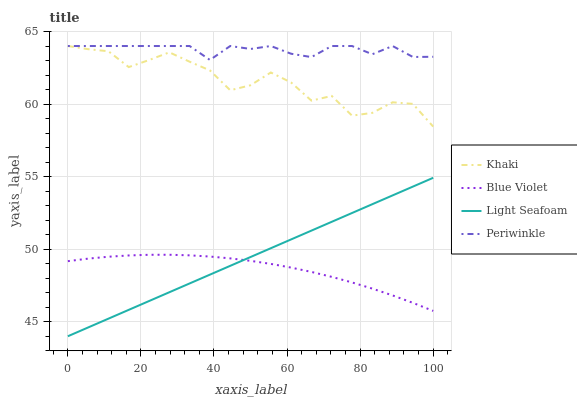Does Khaki have the minimum area under the curve?
Answer yes or no. No. Does Khaki have the maximum area under the curve?
Answer yes or no. No. Is Periwinkle the smoothest?
Answer yes or no. No. Is Periwinkle the roughest?
Answer yes or no. No. Does Khaki have the lowest value?
Answer yes or no. No. Does Blue Violet have the highest value?
Answer yes or no. No. Is Light Seafoam less than Periwinkle?
Answer yes or no. Yes. Is Periwinkle greater than Blue Violet?
Answer yes or no. Yes. Does Light Seafoam intersect Periwinkle?
Answer yes or no. No. 